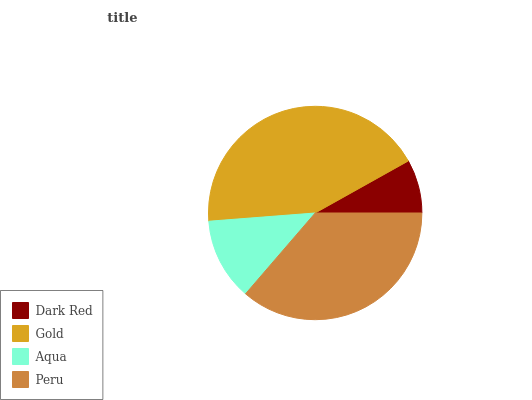Is Dark Red the minimum?
Answer yes or no. Yes. Is Gold the maximum?
Answer yes or no. Yes. Is Aqua the minimum?
Answer yes or no. No. Is Aqua the maximum?
Answer yes or no. No. Is Gold greater than Aqua?
Answer yes or no. Yes. Is Aqua less than Gold?
Answer yes or no. Yes. Is Aqua greater than Gold?
Answer yes or no. No. Is Gold less than Aqua?
Answer yes or no. No. Is Peru the high median?
Answer yes or no. Yes. Is Aqua the low median?
Answer yes or no. Yes. Is Aqua the high median?
Answer yes or no. No. Is Dark Red the low median?
Answer yes or no. No. 